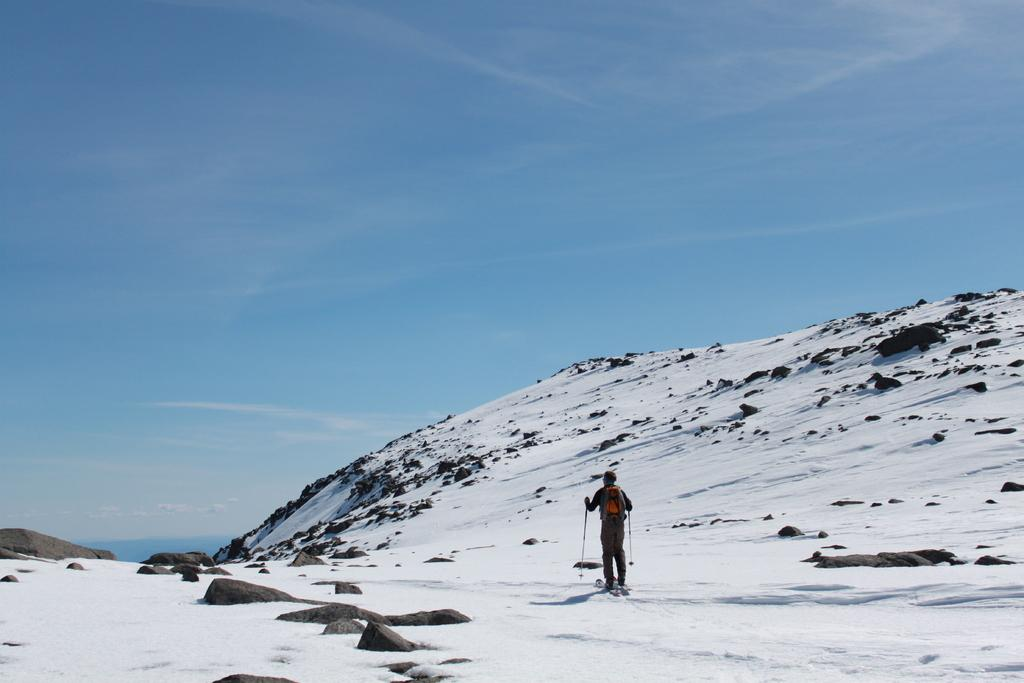Who is present in the image? There is a person in the image. What is the person holding in the image? The person is holding sticks in the image. What activity is the person engaged in? The person is skating on a snow floor in the image. What other elements can be seen on the floor in the image? There are rocks on the floor in the image. How many pies are being served on the rocks in the image? There are no pies present in the image; it features a person skating on a snow floor with rocks. What type of nose does the person have in the image? The image does not provide enough detail to determine the person's nose type. 